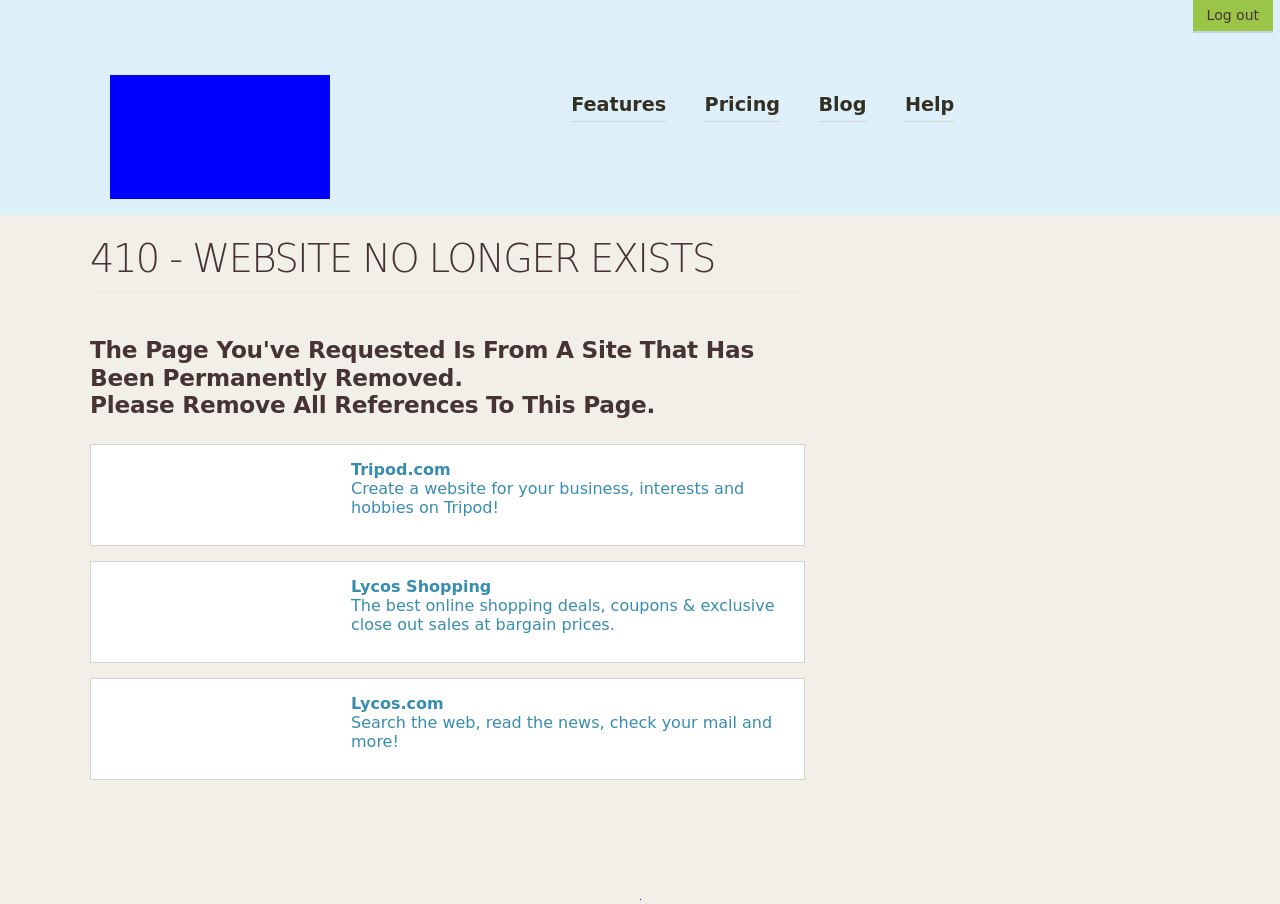What is the significance of the message '410 - Website No Longer Exists' shown on this page? The '410 - Website No Longer Exists' message indicates that the webpage you are attempting to access has been permanently removed from the server. Unlike the '404 Not Found' error which suggests that the page might still be available elsewhere or at a later time, a 410 error is a definitive closure indicating the resource is gone and there is no forwarding address. It's useful for clean-up operations on the web, helping to remove links to dead URLs. 